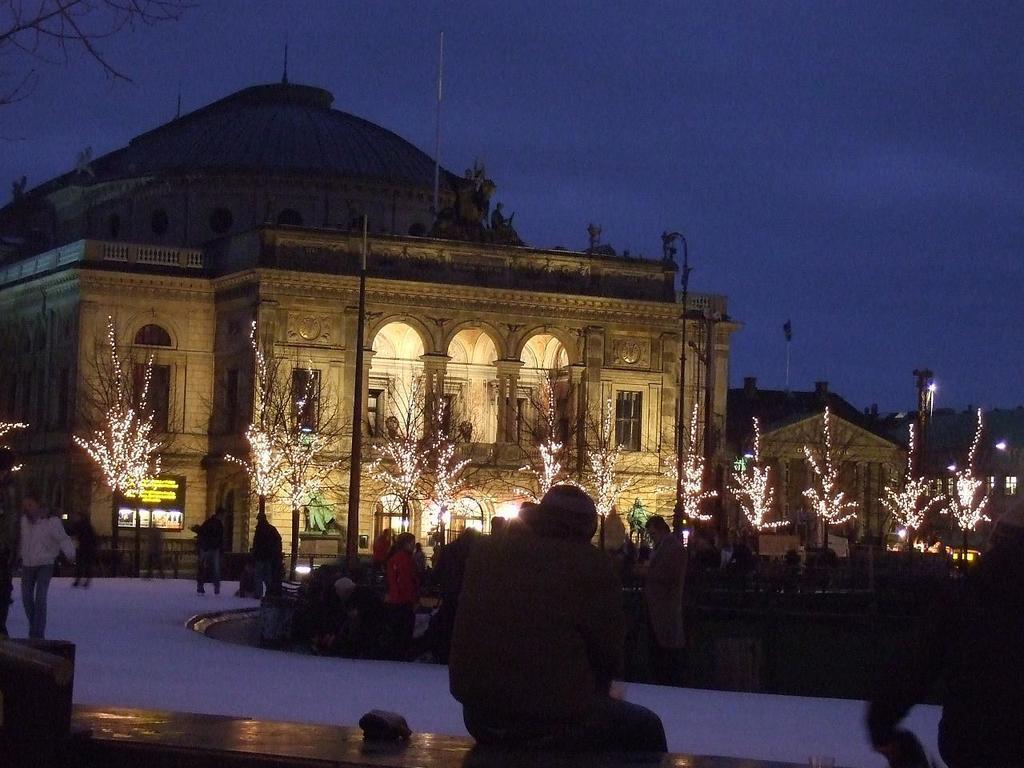Could you give a brief overview of what you see in this image? In this image on a path few people are walking. Here there are few people. In the background there are buildings, trees. On the trees there are lights. The sky is clear. 